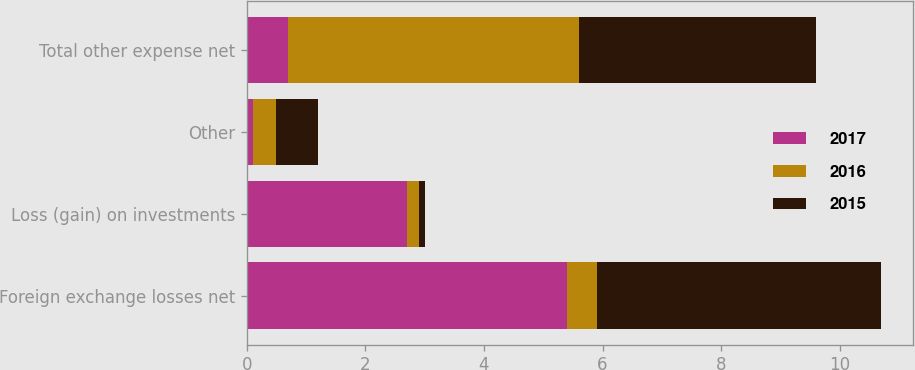Convert chart to OTSL. <chart><loc_0><loc_0><loc_500><loc_500><stacked_bar_chart><ecel><fcel>Foreign exchange losses net<fcel>Loss (gain) on investments<fcel>Other<fcel>Total other expense net<nl><fcel>2017<fcel>5.4<fcel>2.7<fcel>0.1<fcel>0.7<nl><fcel>2016<fcel>0.5<fcel>0.2<fcel>0.4<fcel>4.9<nl><fcel>2015<fcel>4.8<fcel>0.1<fcel>0.7<fcel>4<nl></chart> 